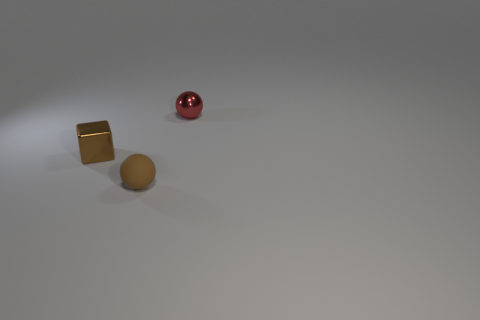Add 1 small metallic spheres. How many objects exist? 4 Subtract all spheres. How many objects are left? 1 Subtract 1 spheres. How many spheres are left? 1 Subtract all purple spheres. How many yellow cubes are left? 0 Subtract 1 brown cubes. How many objects are left? 2 Subtract all brown balls. Subtract all cyan cylinders. How many balls are left? 1 Subtract all red spheres. Subtract all red matte cylinders. How many objects are left? 2 Add 1 small brown spheres. How many small brown spheres are left? 2 Add 2 blocks. How many blocks exist? 3 